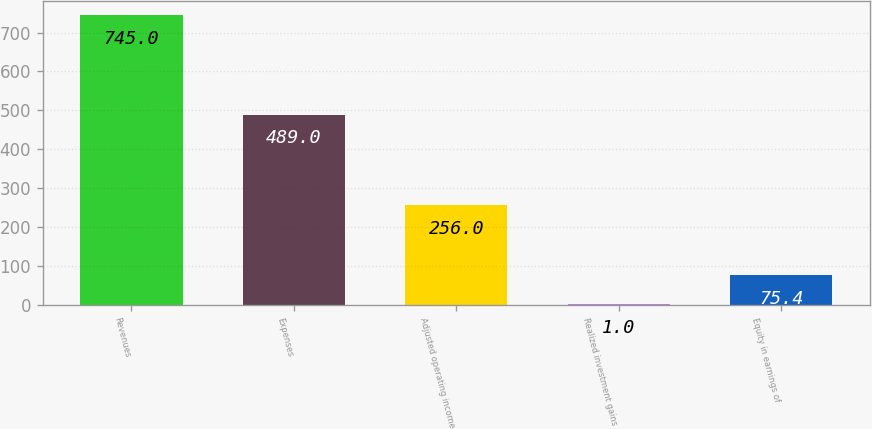Convert chart to OTSL. <chart><loc_0><loc_0><loc_500><loc_500><bar_chart><fcel>Revenues<fcel>Expenses<fcel>Adjusted operating income<fcel>Realized investment gains<fcel>Equity in earnings of<nl><fcel>745<fcel>489<fcel>256<fcel>1<fcel>75.4<nl></chart> 